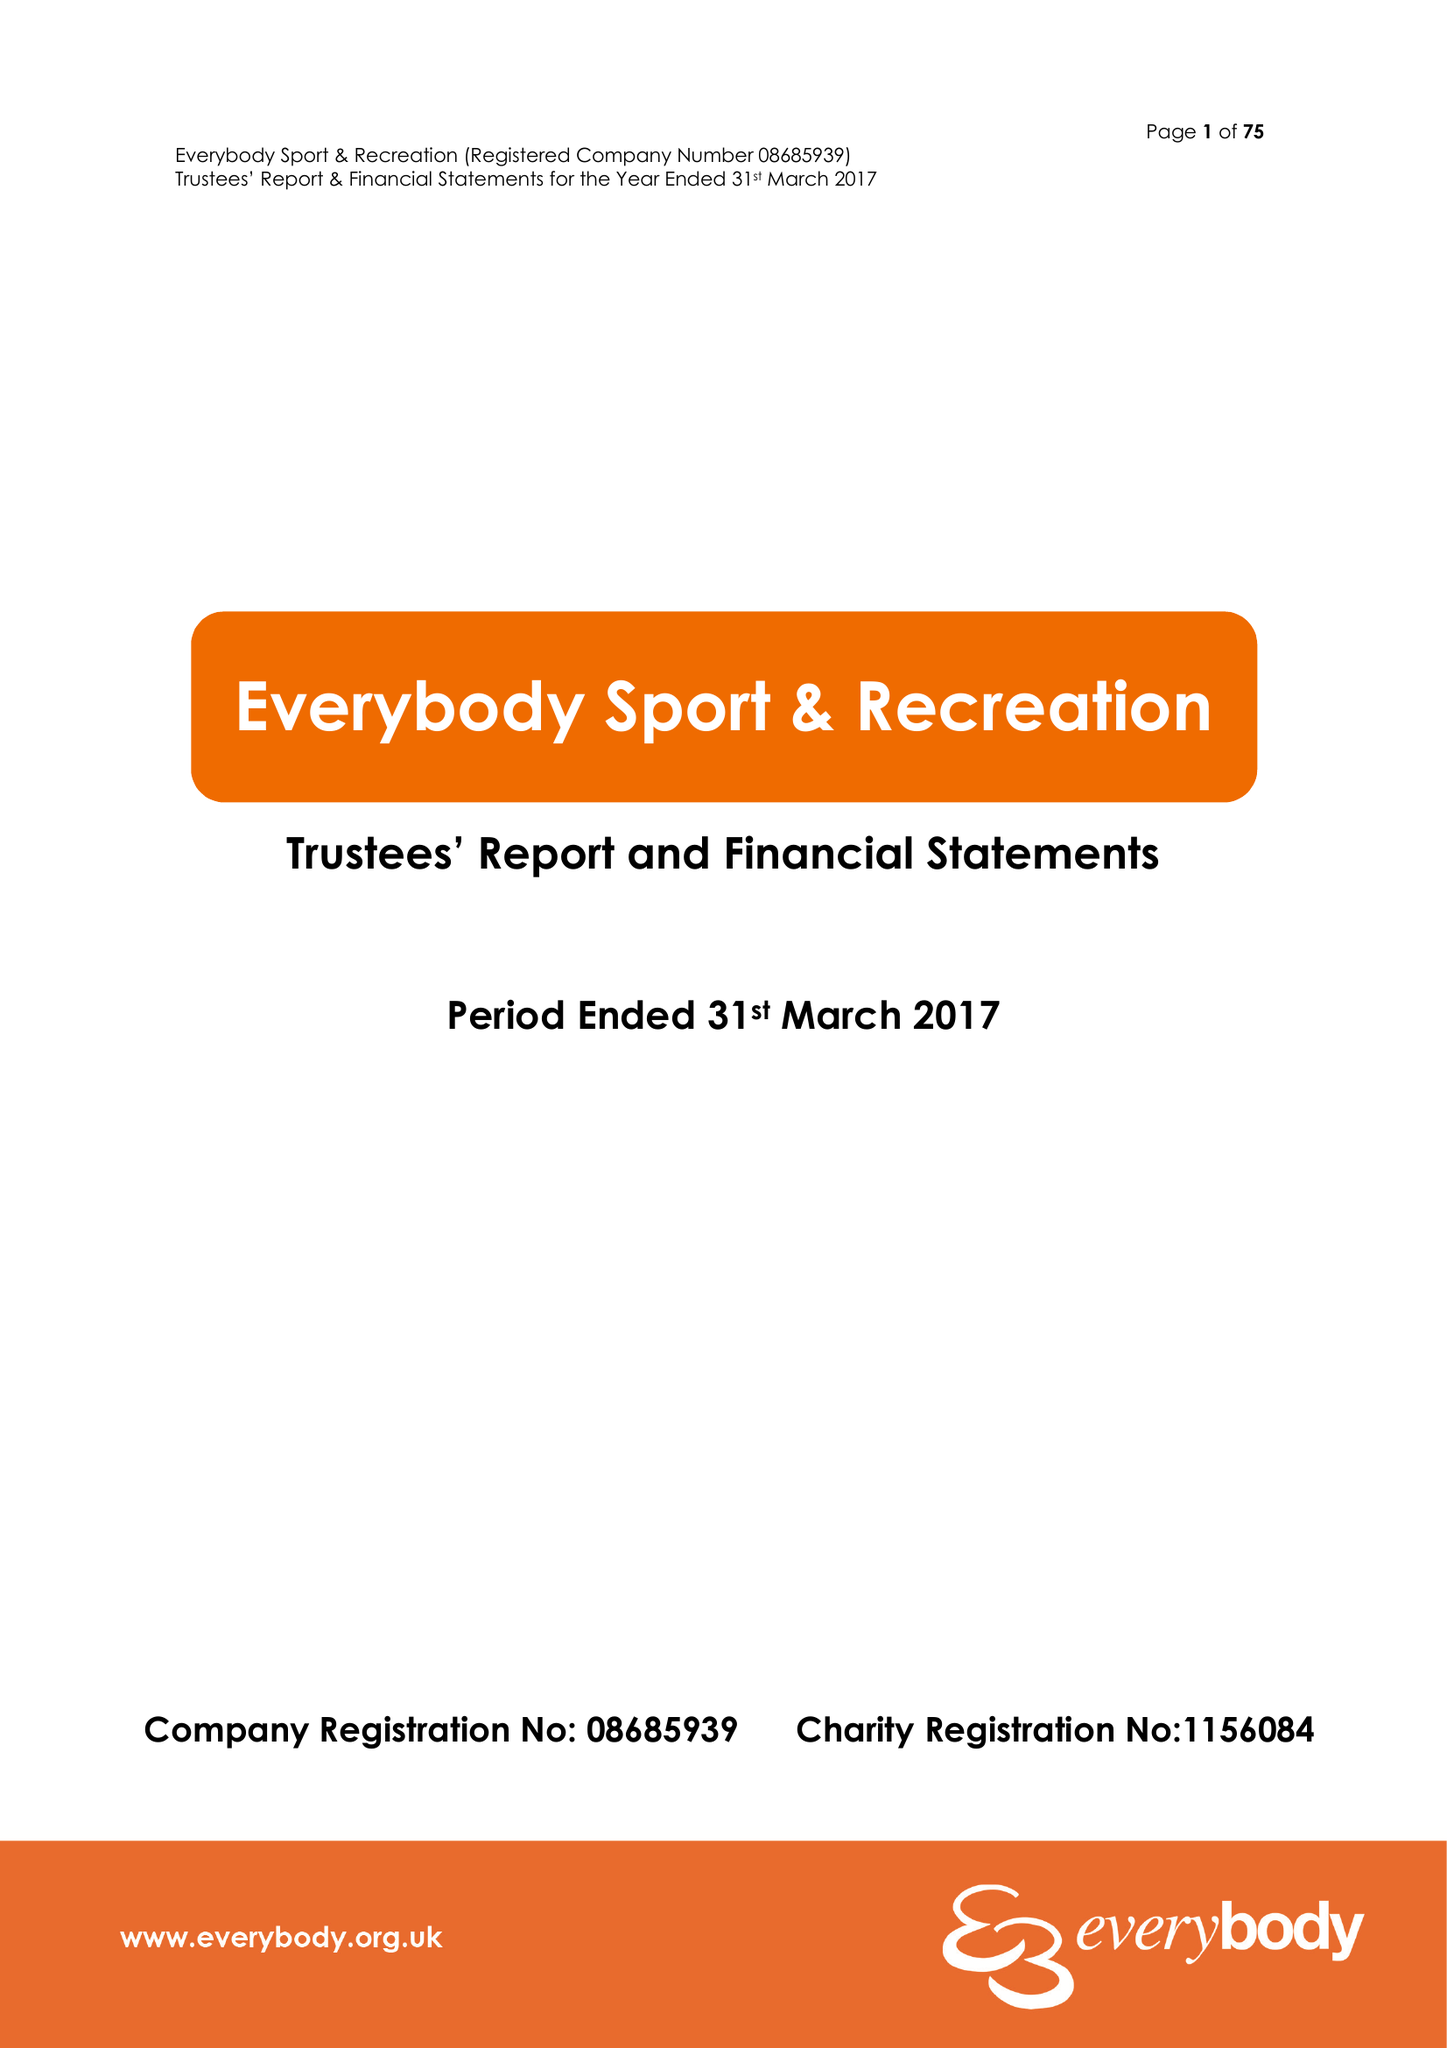What is the value for the report_date?
Answer the question using a single word or phrase. 2017-03-31 